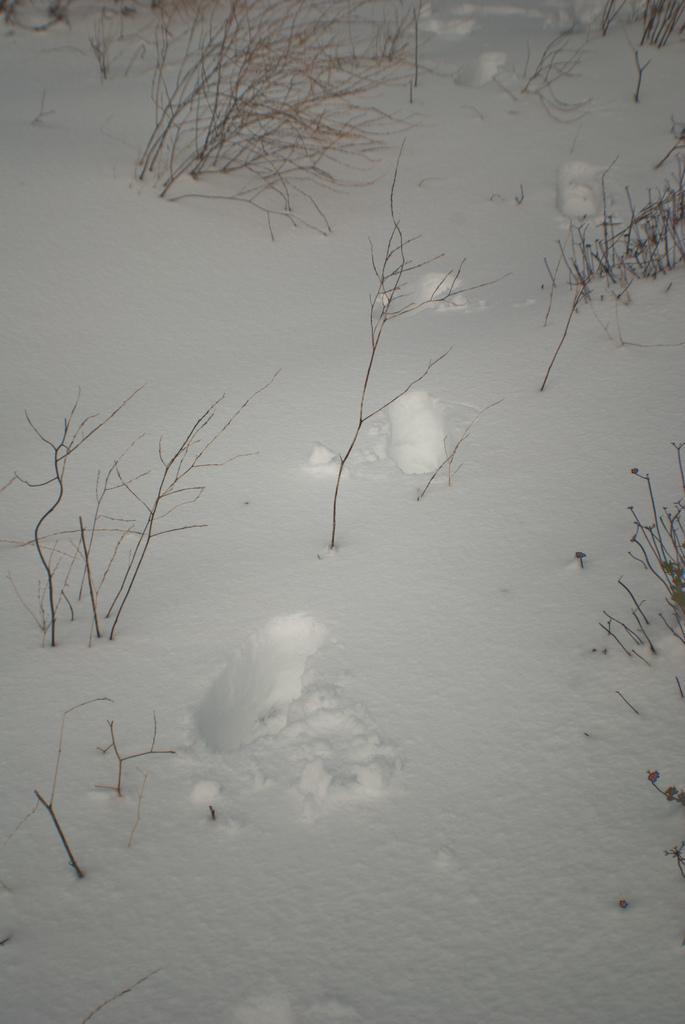Please provide a concise description of this image. In the image we can see there are dry plants on the ground and there is snow on the ground. 